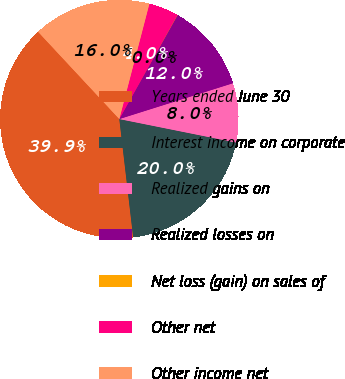Convert chart to OTSL. <chart><loc_0><loc_0><loc_500><loc_500><pie_chart><fcel>Years ended June 30<fcel>Interest income on corporate<fcel>Realized gains on<fcel>Realized losses on<fcel>Net loss (gain) on sales of<fcel>Other net<fcel>Other income net<nl><fcel>39.92%<fcel>19.98%<fcel>8.02%<fcel>12.01%<fcel>0.04%<fcel>4.03%<fcel>15.99%<nl></chart> 